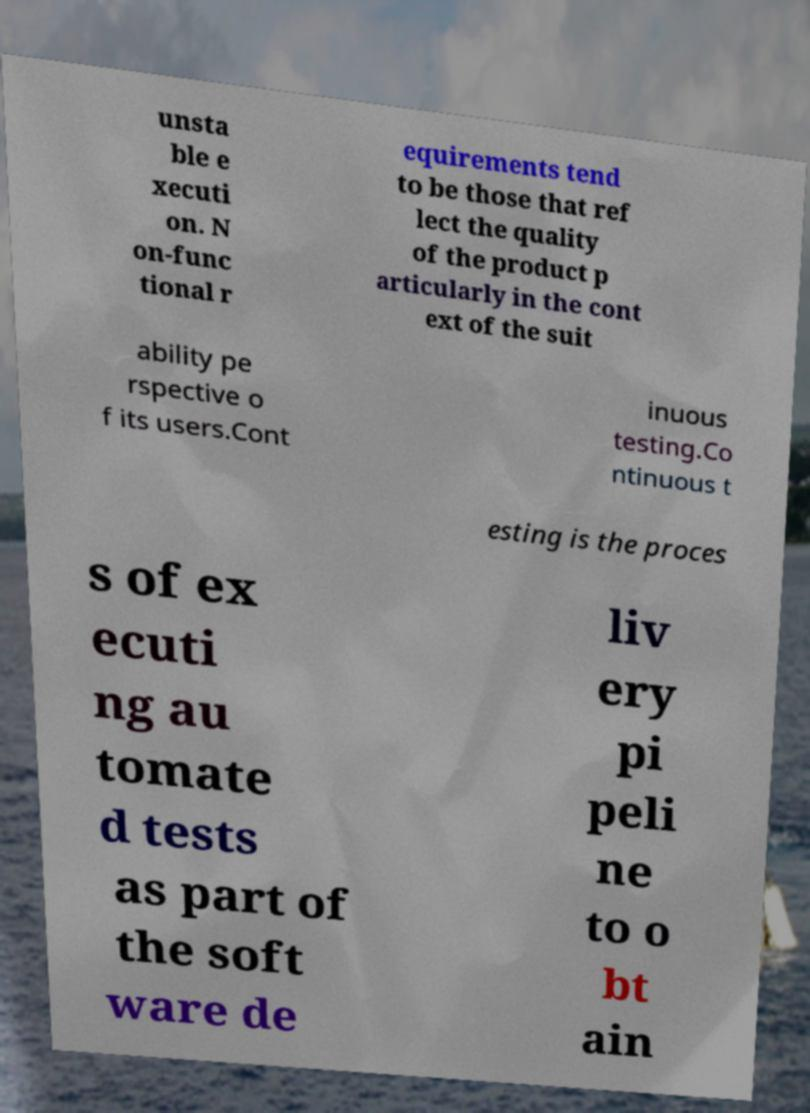What messages or text are displayed in this image? I need them in a readable, typed format. unsta ble e xecuti on. N on-func tional r equirements tend to be those that ref lect the quality of the product p articularly in the cont ext of the suit ability pe rspective o f its users.Cont inuous testing.Co ntinuous t esting is the proces s of ex ecuti ng au tomate d tests as part of the soft ware de liv ery pi peli ne to o bt ain 